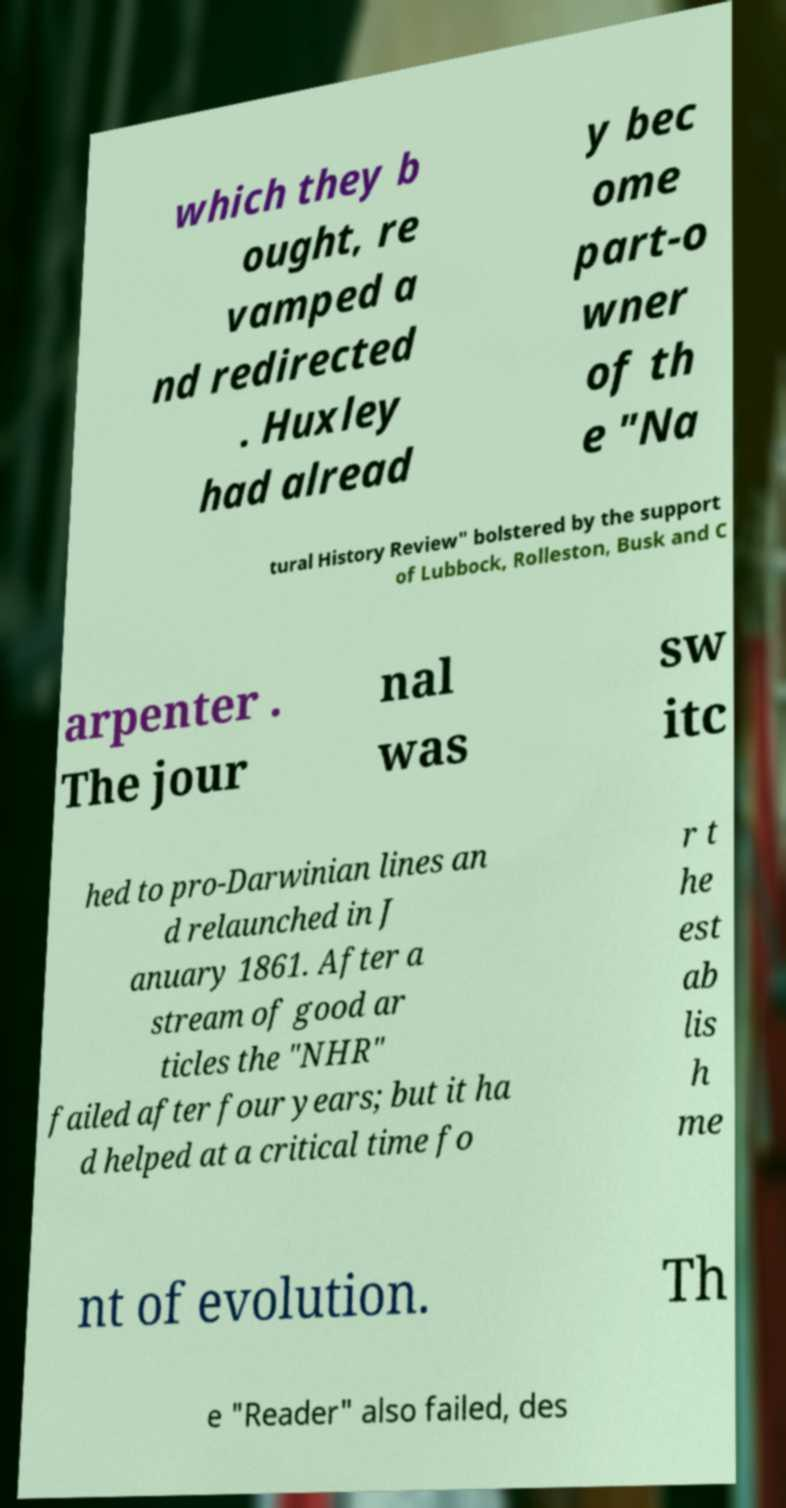For documentation purposes, I need the text within this image transcribed. Could you provide that? which they b ought, re vamped a nd redirected . Huxley had alread y bec ome part-o wner of th e "Na tural History Review" bolstered by the support of Lubbock, Rolleston, Busk and C arpenter . The jour nal was sw itc hed to pro-Darwinian lines an d relaunched in J anuary 1861. After a stream of good ar ticles the "NHR" failed after four years; but it ha d helped at a critical time fo r t he est ab lis h me nt of evolution. Th e "Reader" also failed, des 